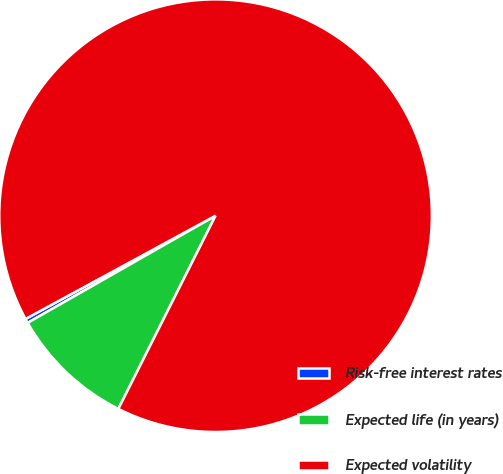<chart> <loc_0><loc_0><loc_500><loc_500><pie_chart><fcel>Risk-free interest rates<fcel>Expected life (in years)<fcel>Expected volatility<nl><fcel>0.33%<fcel>9.33%<fcel>90.34%<nl></chart> 